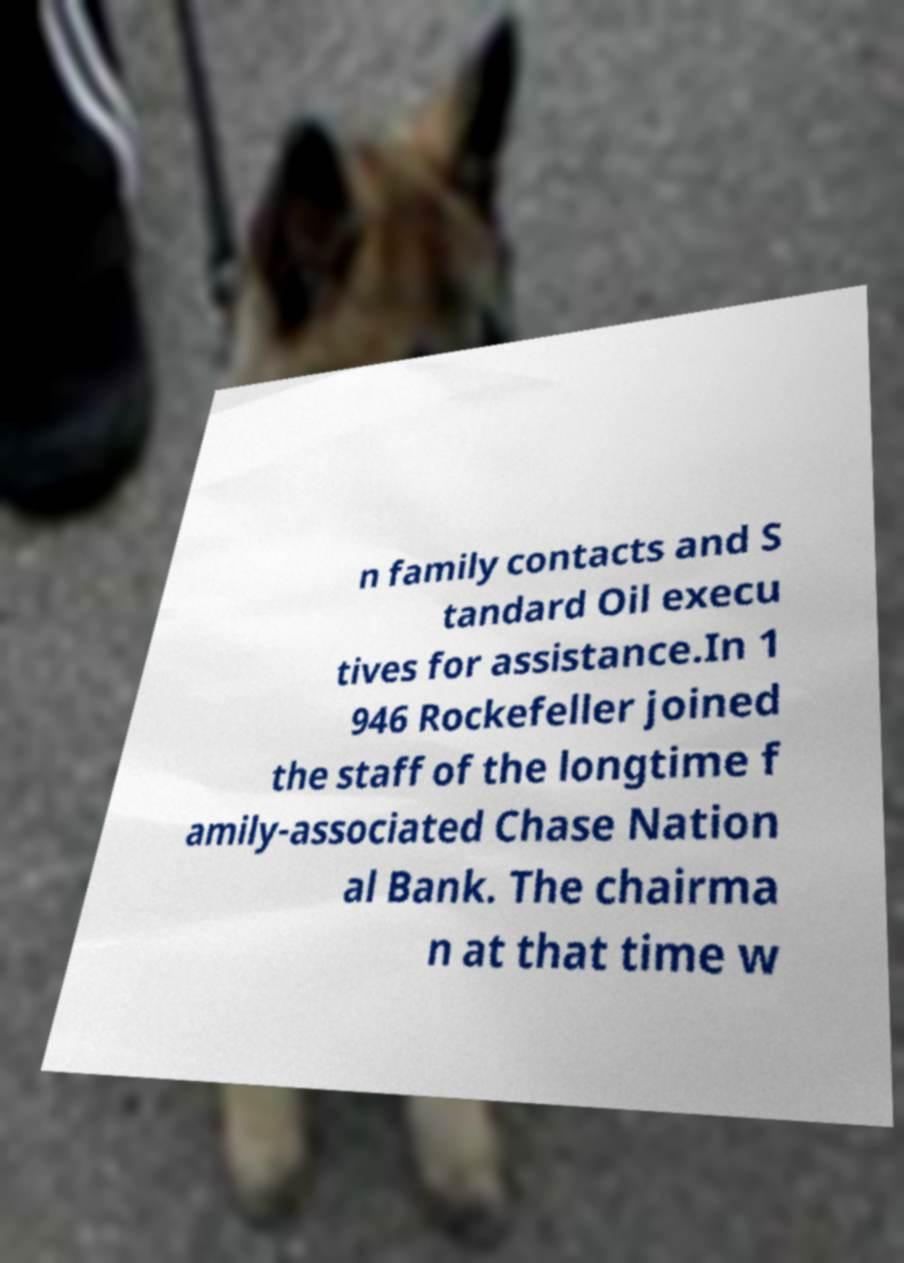Can you read and provide the text displayed in the image?This photo seems to have some interesting text. Can you extract and type it out for me? n family contacts and S tandard Oil execu tives for assistance.In 1 946 Rockefeller joined the staff of the longtime f amily-associated Chase Nation al Bank. The chairma n at that time w 